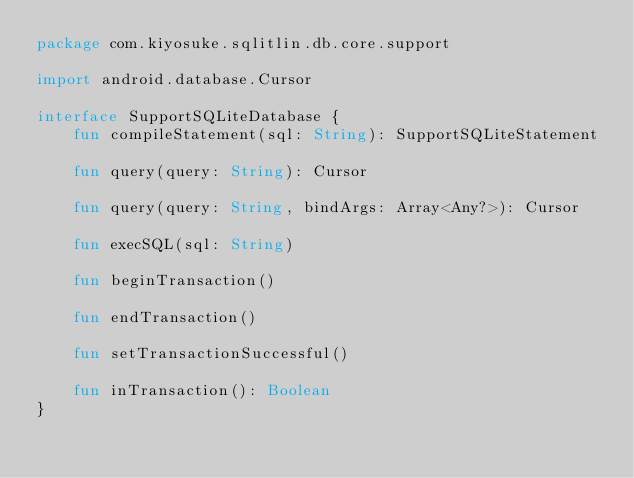<code> <loc_0><loc_0><loc_500><loc_500><_Kotlin_>package com.kiyosuke.sqlitlin.db.core.support

import android.database.Cursor

interface SupportSQLiteDatabase {
    fun compileStatement(sql: String): SupportSQLiteStatement

    fun query(query: String): Cursor

    fun query(query: String, bindArgs: Array<Any?>): Cursor

    fun execSQL(sql: String)

    fun beginTransaction()

    fun endTransaction()

    fun setTransactionSuccessful()

    fun inTransaction(): Boolean
}</code> 